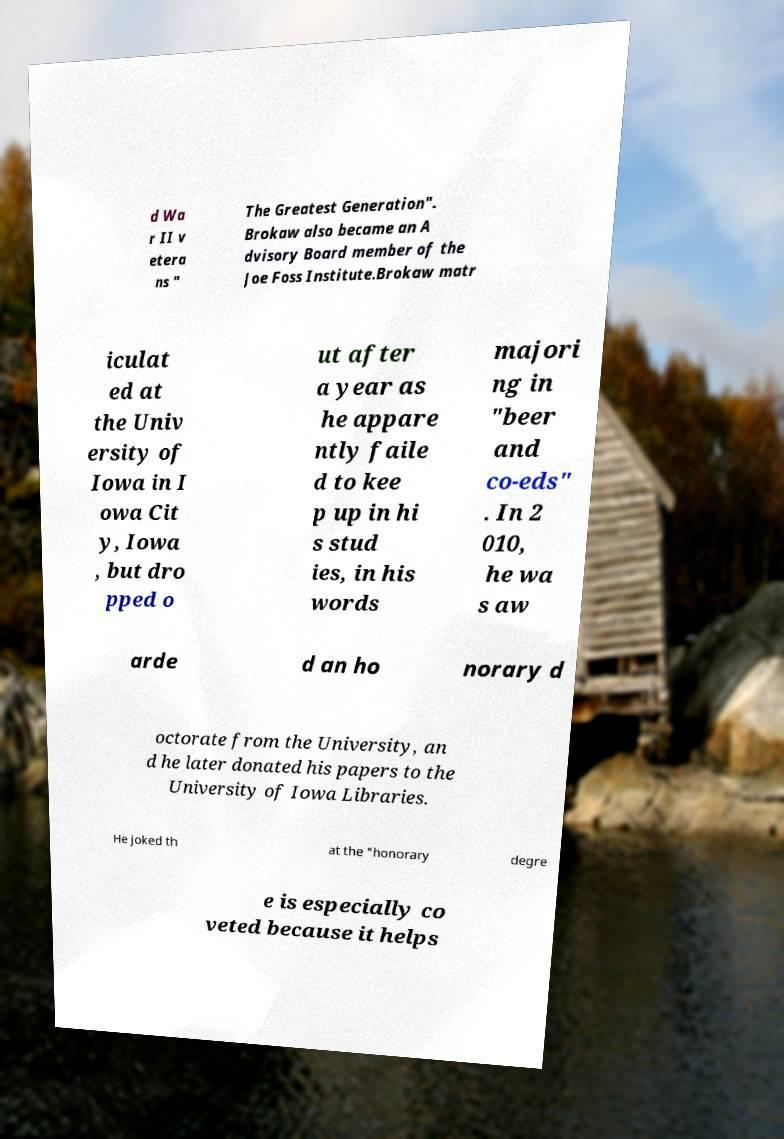There's text embedded in this image that I need extracted. Can you transcribe it verbatim? d Wa r II v etera ns " The Greatest Generation". Brokaw also became an A dvisory Board member of the Joe Foss Institute.Brokaw matr iculat ed at the Univ ersity of Iowa in I owa Cit y, Iowa , but dro pped o ut after a year as he appare ntly faile d to kee p up in hi s stud ies, in his words majori ng in "beer and co-eds" . In 2 010, he wa s aw arde d an ho norary d octorate from the University, an d he later donated his papers to the University of Iowa Libraries. He joked th at the "honorary degre e is especially co veted because it helps 